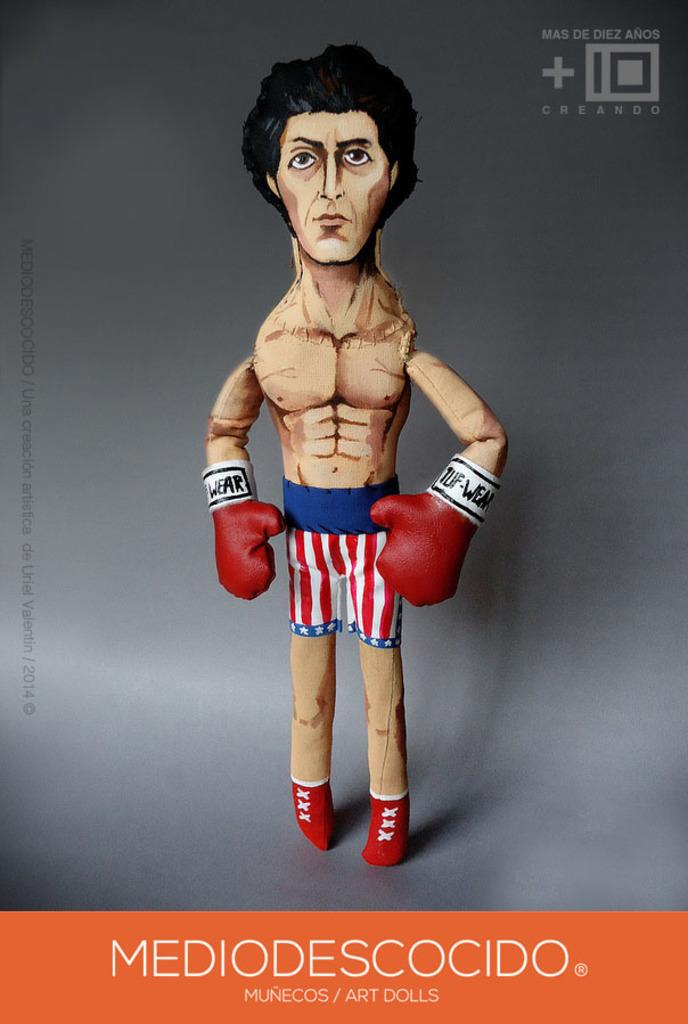<image>
Relay a brief, clear account of the picture shown. An ad for an Art Doll by Mediodescocido. 